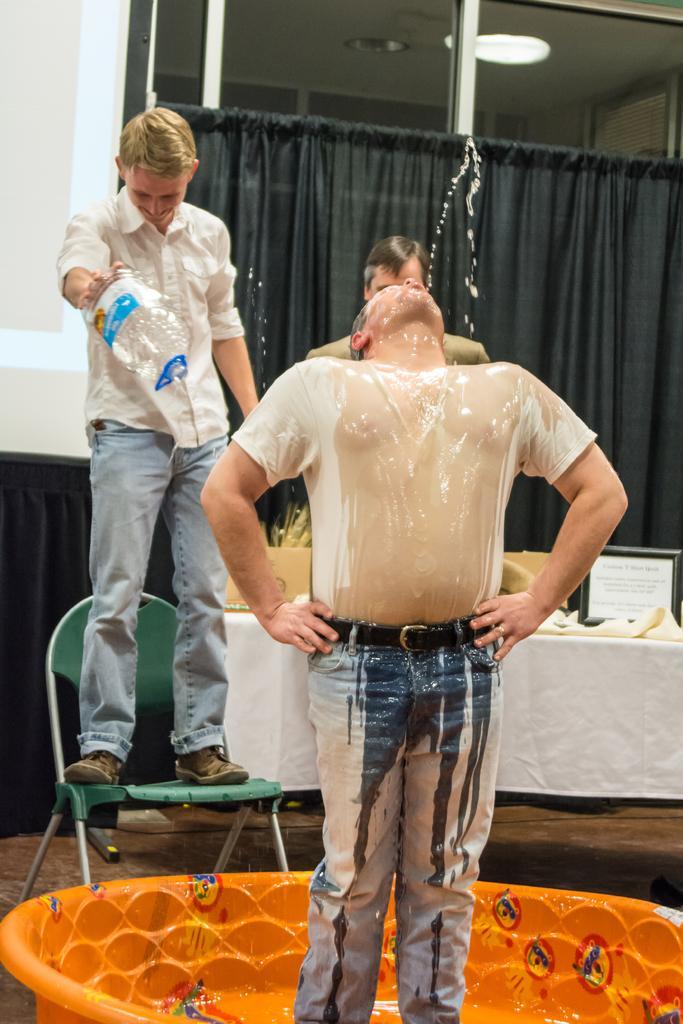In one or two sentences, can you explain what this image depicts? In this picture, we see a man is standing in an orange color inflatable bathtub. He might be drinking the water from the pipe. On the left side, we see a man in the white shirt is standing on the chair. He is smiling. Behind him, we see a black curtain and a white wall. Beside him, we see a man is standing. Behind him, we see a table which is covered with a white color cloth. We see a monitor, white cloth and some other objects on the table. In the background, we see a curtain in black color. At the top, we see the lights and the ceiling of the room. 